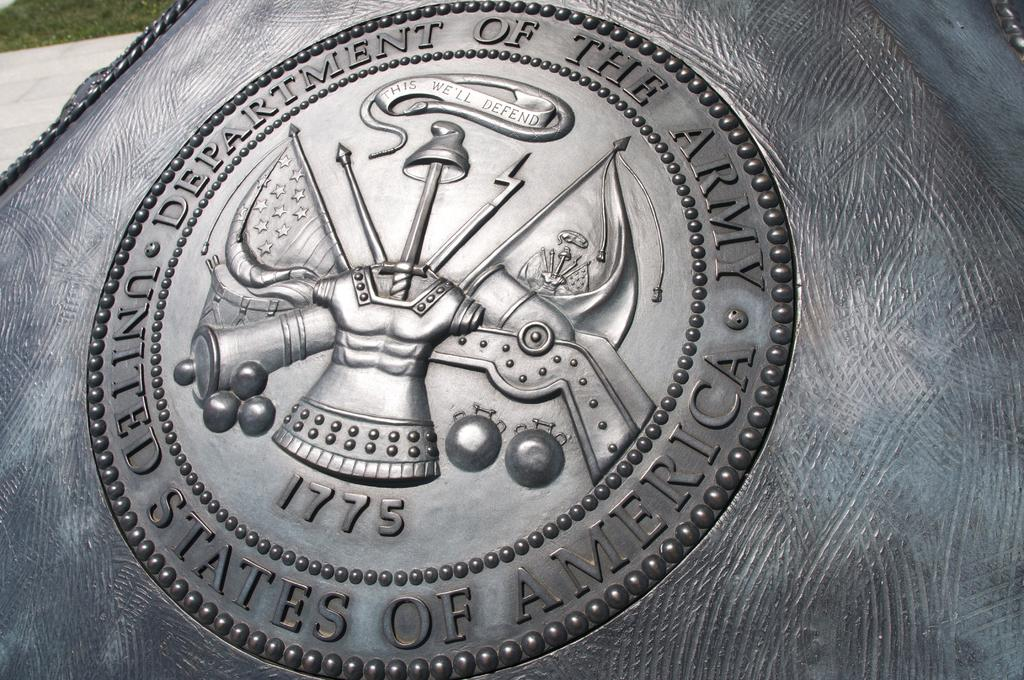Provide a one-sentence caption for the provided image. silver coin or plaque that s says department of the army. 